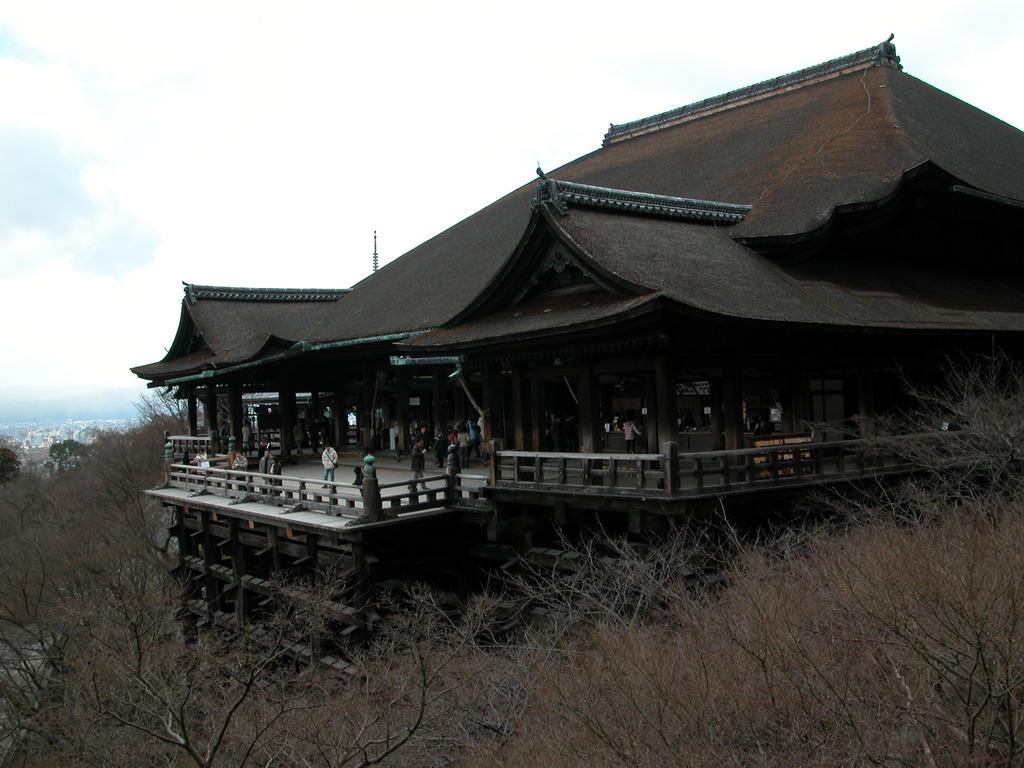What type of structure can be seen in the image? There is a building in the image. What natural elements are present in the image? There are trees and mountains visible in the image. Can you describe the people in the image? There are people in the image, but their specific actions or characteristics are not mentioned in the facts. What architectural features can be seen in the image? There is a fence and pillars visible in the image. What is visible in the background of the image? Mountains, the sky, and clouds are visible in the background of the image. How much money is being exchanged between the people in the image? There is no mention of money or any exchange of money in the image. What type of wax is being used to create the pillars in the image? There is no mention of wax or any material used to create the pillars in the image. 